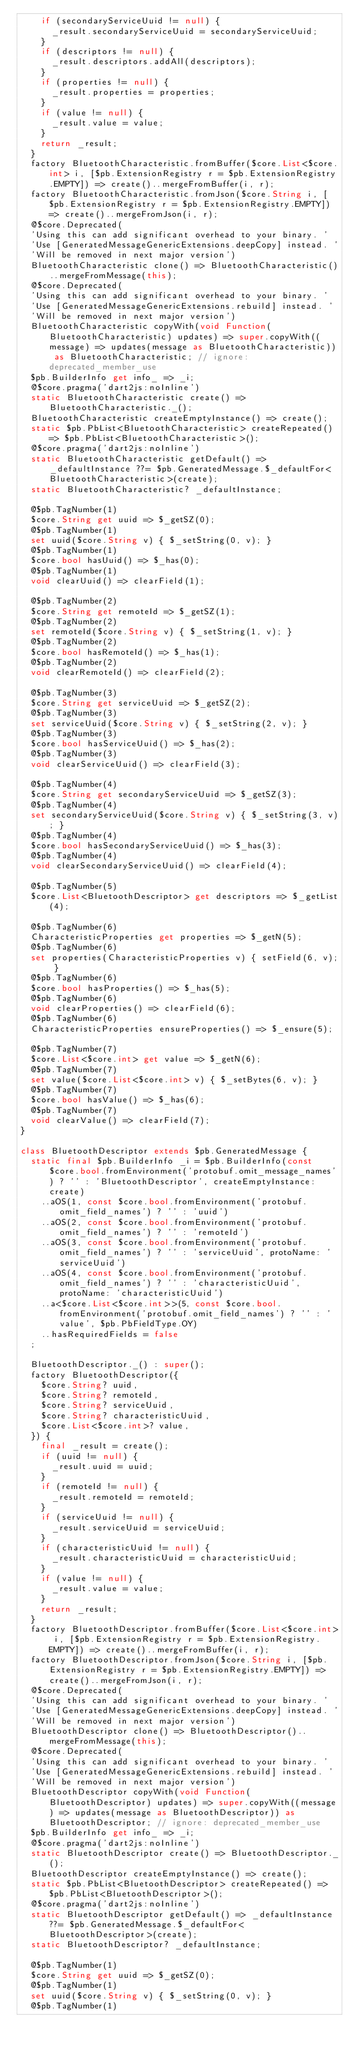<code> <loc_0><loc_0><loc_500><loc_500><_Dart_>    if (secondaryServiceUuid != null) {
      _result.secondaryServiceUuid = secondaryServiceUuid;
    }
    if (descriptors != null) {
      _result.descriptors.addAll(descriptors);
    }
    if (properties != null) {
      _result.properties = properties;
    }
    if (value != null) {
      _result.value = value;
    }
    return _result;
  }
  factory BluetoothCharacteristic.fromBuffer($core.List<$core.int> i, [$pb.ExtensionRegistry r = $pb.ExtensionRegistry.EMPTY]) => create()..mergeFromBuffer(i, r);
  factory BluetoothCharacteristic.fromJson($core.String i, [$pb.ExtensionRegistry r = $pb.ExtensionRegistry.EMPTY]) => create()..mergeFromJson(i, r);
  @$core.Deprecated(
  'Using this can add significant overhead to your binary. '
  'Use [GeneratedMessageGenericExtensions.deepCopy] instead. '
  'Will be removed in next major version')
  BluetoothCharacteristic clone() => BluetoothCharacteristic()..mergeFromMessage(this);
  @$core.Deprecated(
  'Using this can add significant overhead to your binary. '
  'Use [GeneratedMessageGenericExtensions.rebuild] instead. '
  'Will be removed in next major version')
  BluetoothCharacteristic copyWith(void Function(BluetoothCharacteristic) updates) => super.copyWith((message) => updates(message as BluetoothCharacteristic)) as BluetoothCharacteristic; // ignore: deprecated_member_use
  $pb.BuilderInfo get info_ => _i;
  @$core.pragma('dart2js:noInline')
  static BluetoothCharacteristic create() => BluetoothCharacteristic._();
  BluetoothCharacteristic createEmptyInstance() => create();
  static $pb.PbList<BluetoothCharacteristic> createRepeated() => $pb.PbList<BluetoothCharacteristic>();
  @$core.pragma('dart2js:noInline')
  static BluetoothCharacteristic getDefault() => _defaultInstance ??= $pb.GeneratedMessage.$_defaultFor<BluetoothCharacteristic>(create);
  static BluetoothCharacteristic? _defaultInstance;

  @$pb.TagNumber(1)
  $core.String get uuid => $_getSZ(0);
  @$pb.TagNumber(1)
  set uuid($core.String v) { $_setString(0, v); }
  @$pb.TagNumber(1)
  $core.bool hasUuid() => $_has(0);
  @$pb.TagNumber(1)
  void clearUuid() => clearField(1);

  @$pb.TagNumber(2)
  $core.String get remoteId => $_getSZ(1);
  @$pb.TagNumber(2)
  set remoteId($core.String v) { $_setString(1, v); }
  @$pb.TagNumber(2)
  $core.bool hasRemoteId() => $_has(1);
  @$pb.TagNumber(2)
  void clearRemoteId() => clearField(2);

  @$pb.TagNumber(3)
  $core.String get serviceUuid => $_getSZ(2);
  @$pb.TagNumber(3)
  set serviceUuid($core.String v) { $_setString(2, v); }
  @$pb.TagNumber(3)
  $core.bool hasServiceUuid() => $_has(2);
  @$pb.TagNumber(3)
  void clearServiceUuid() => clearField(3);

  @$pb.TagNumber(4)
  $core.String get secondaryServiceUuid => $_getSZ(3);
  @$pb.TagNumber(4)
  set secondaryServiceUuid($core.String v) { $_setString(3, v); }
  @$pb.TagNumber(4)
  $core.bool hasSecondaryServiceUuid() => $_has(3);
  @$pb.TagNumber(4)
  void clearSecondaryServiceUuid() => clearField(4);

  @$pb.TagNumber(5)
  $core.List<BluetoothDescriptor> get descriptors => $_getList(4);

  @$pb.TagNumber(6)
  CharacteristicProperties get properties => $_getN(5);
  @$pb.TagNumber(6)
  set properties(CharacteristicProperties v) { setField(6, v); }
  @$pb.TagNumber(6)
  $core.bool hasProperties() => $_has(5);
  @$pb.TagNumber(6)
  void clearProperties() => clearField(6);
  @$pb.TagNumber(6)
  CharacteristicProperties ensureProperties() => $_ensure(5);

  @$pb.TagNumber(7)
  $core.List<$core.int> get value => $_getN(6);
  @$pb.TagNumber(7)
  set value($core.List<$core.int> v) { $_setBytes(6, v); }
  @$pb.TagNumber(7)
  $core.bool hasValue() => $_has(6);
  @$pb.TagNumber(7)
  void clearValue() => clearField(7);
}

class BluetoothDescriptor extends $pb.GeneratedMessage {
  static final $pb.BuilderInfo _i = $pb.BuilderInfo(const $core.bool.fromEnvironment('protobuf.omit_message_names') ? '' : 'BluetoothDescriptor', createEmptyInstance: create)
    ..aOS(1, const $core.bool.fromEnvironment('protobuf.omit_field_names') ? '' : 'uuid')
    ..aOS(2, const $core.bool.fromEnvironment('protobuf.omit_field_names') ? '' : 'remoteId')
    ..aOS(3, const $core.bool.fromEnvironment('protobuf.omit_field_names') ? '' : 'serviceUuid', protoName: 'serviceUuid')
    ..aOS(4, const $core.bool.fromEnvironment('protobuf.omit_field_names') ? '' : 'characteristicUuid', protoName: 'characteristicUuid')
    ..a<$core.List<$core.int>>(5, const $core.bool.fromEnvironment('protobuf.omit_field_names') ? '' : 'value', $pb.PbFieldType.OY)
    ..hasRequiredFields = false
  ;

  BluetoothDescriptor._() : super();
  factory BluetoothDescriptor({
    $core.String? uuid,
    $core.String? remoteId,
    $core.String? serviceUuid,
    $core.String? characteristicUuid,
    $core.List<$core.int>? value,
  }) {
    final _result = create();
    if (uuid != null) {
      _result.uuid = uuid;
    }
    if (remoteId != null) {
      _result.remoteId = remoteId;
    }
    if (serviceUuid != null) {
      _result.serviceUuid = serviceUuid;
    }
    if (characteristicUuid != null) {
      _result.characteristicUuid = characteristicUuid;
    }
    if (value != null) {
      _result.value = value;
    }
    return _result;
  }
  factory BluetoothDescriptor.fromBuffer($core.List<$core.int> i, [$pb.ExtensionRegistry r = $pb.ExtensionRegistry.EMPTY]) => create()..mergeFromBuffer(i, r);
  factory BluetoothDescriptor.fromJson($core.String i, [$pb.ExtensionRegistry r = $pb.ExtensionRegistry.EMPTY]) => create()..mergeFromJson(i, r);
  @$core.Deprecated(
  'Using this can add significant overhead to your binary. '
  'Use [GeneratedMessageGenericExtensions.deepCopy] instead. '
  'Will be removed in next major version')
  BluetoothDescriptor clone() => BluetoothDescriptor()..mergeFromMessage(this);
  @$core.Deprecated(
  'Using this can add significant overhead to your binary. '
  'Use [GeneratedMessageGenericExtensions.rebuild] instead. '
  'Will be removed in next major version')
  BluetoothDescriptor copyWith(void Function(BluetoothDescriptor) updates) => super.copyWith((message) => updates(message as BluetoothDescriptor)) as BluetoothDescriptor; // ignore: deprecated_member_use
  $pb.BuilderInfo get info_ => _i;
  @$core.pragma('dart2js:noInline')
  static BluetoothDescriptor create() => BluetoothDescriptor._();
  BluetoothDescriptor createEmptyInstance() => create();
  static $pb.PbList<BluetoothDescriptor> createRepeated() => $pb.PbList<BluetoothDescriptor>();
  @$core.pragma('dart2js:noInline')
  static BluetoothDescriptor getDefault() => _defaultInstance ??= $pb.GeneratedMessage.$_defaultFor<BluetoothDescriptor>(create);
  static BluetoothDescriptor? _defaultInstance;

  @$pb.TagNumber(1)
  $core.String get uuid => $_getSZ(0);
  @$pb.TagNumber(1)
  set uuid($core.String v) { $_setString(0, v); }
  @$pb.TagNumber(1)</code> 